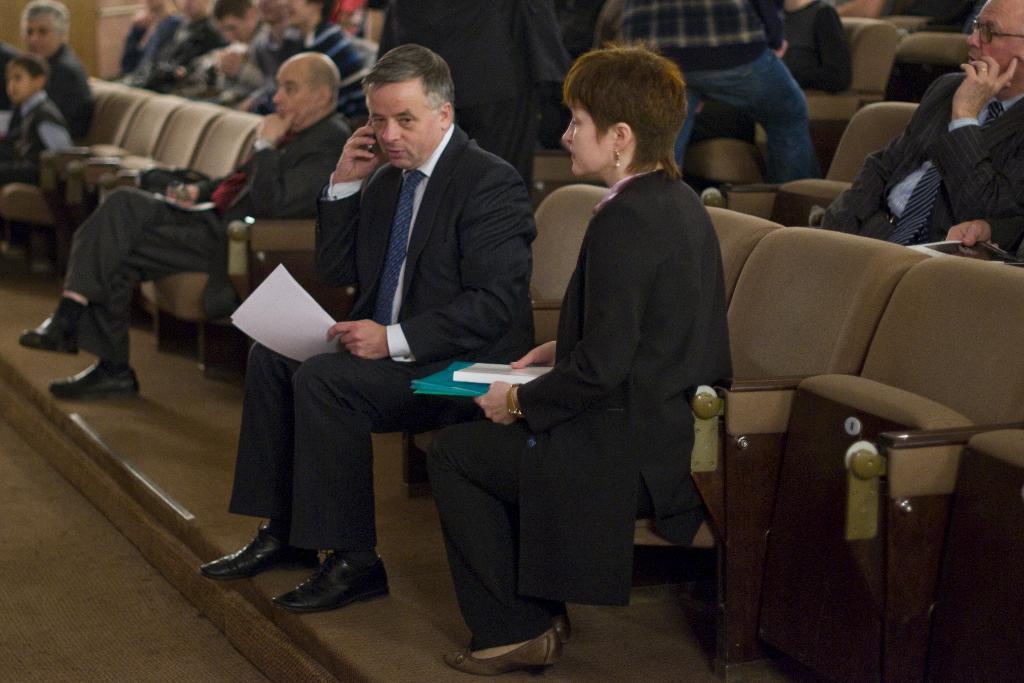Can you describe this image briefly? In this image i can see a group of people who are sitting on a chair. 